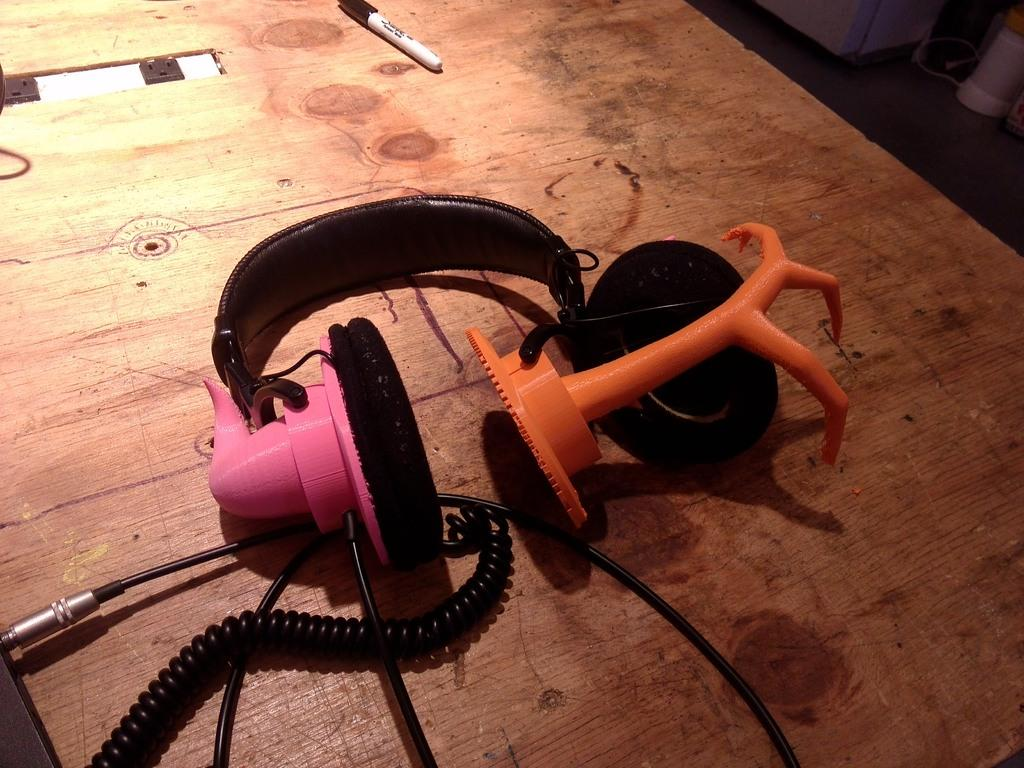What type of device is in the image? There is a headset in the image. What stationary object is also present in the image? There is a pen in the image. What connects the headset and the pen in the image? Wires are visible in the image. Where are the headset, pen, and wires located in the image? The headset, pen, and wires are on a table. How many legs does the toad have in the image? There is no toad present in the image. What type of step is shown in the image? There is no step or staircase present in the image. 